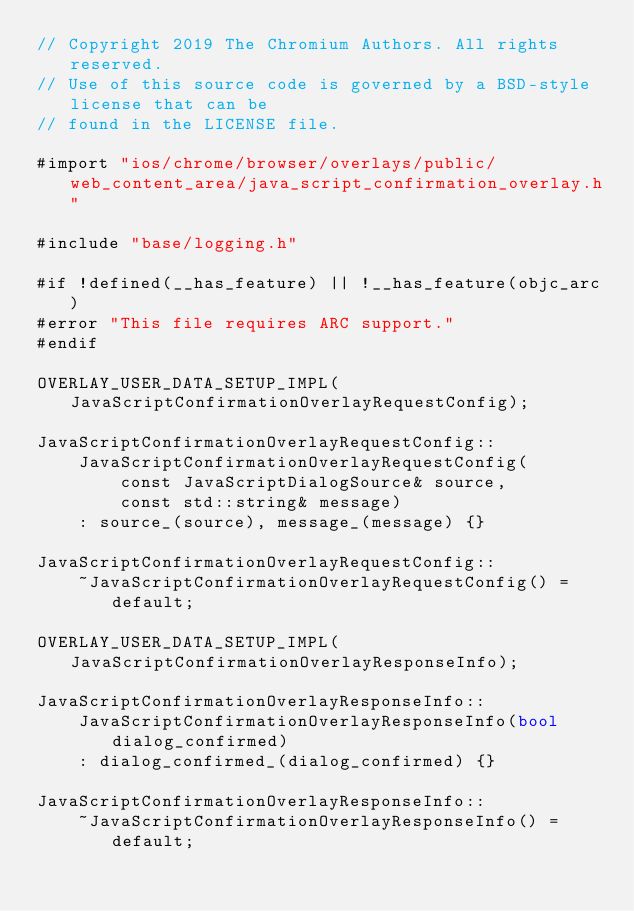<code> <loc_0><loc_0><loc_500><loc_500><_ObjectiveC_>// Copyright 2019 The Chromium Authors. All rights reserved.
// Use of this source code is governed by a BSD-style license that can be
// found in the LICENSE file.

#import "ios/chrome/browser/overlays/public/web_content_area/java_script_confirmation_overlay.h"

#include "base/logging.h"

#if !defined(__has_feature) || !__has_feature(objc_arc)
#error "This file requires ARC support."
#endif

OVERLAY_USER_DATA_SETUP_IMPL(JavaScriptConfirmationOverlayRequestConfig);

JavaScriptConfirmationOverlayRequestConfig::
    JavaScriptConfirmationOverlayRequestConfig(
        const JavaScriptDialogSource& source,
        const std::string& message)
    : source_(source), message_(message) {}

JavaScriptConfirmationOverlayRequestConfig::
    ~JavaScriptConfirmationOverlayRequestConfig() = default;

OVERLAY_USER_DATA_SETUP_IMPL(JavaScriptConfirmationOverlayResponseInfo);

JavaScriptConfirmationOverlayResponseInfo::
    JavaScriptConfirmationOverlayResponseInfo(bool dialog_confirmed)
    : dialog_confirmed_(dialog_confirmed) {}

JavaScriptConfirmationOverlayResponseInfo::
    ~JavaScriptConfirmationOverlayResponseInfo() = default;
</code> 